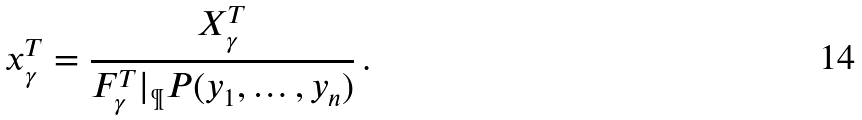Convert formula to latex. <formula><loc_0><loc_0><loc_500><loc_500>x _ { \gamma } ^ { T } = \frac { X _ { \gamma } ^ { T } } { F _ { \gamma } ^ { T } | _ { \P } P ( y _ { 1 } , \dots , y _ { n } ) } \, .</formula> 